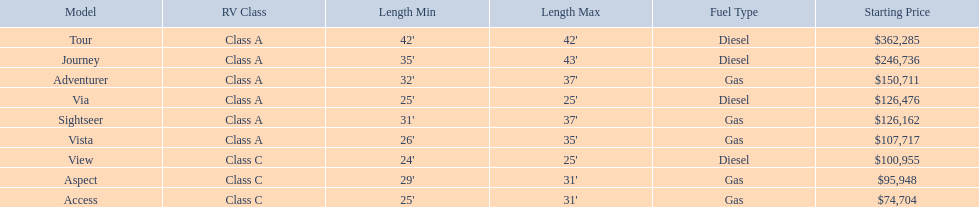What models are available from winnebago industries? Tour, Journey, Adventurer, Via, Sightseer, Vista, View, Aspect, Access. What are their starting prices? $362,285, $246,736, $150,711, $126,476, $126,162, $107,717, $100,955, $95,948, $74,704. Which model has the most costly starting price? Tour. 